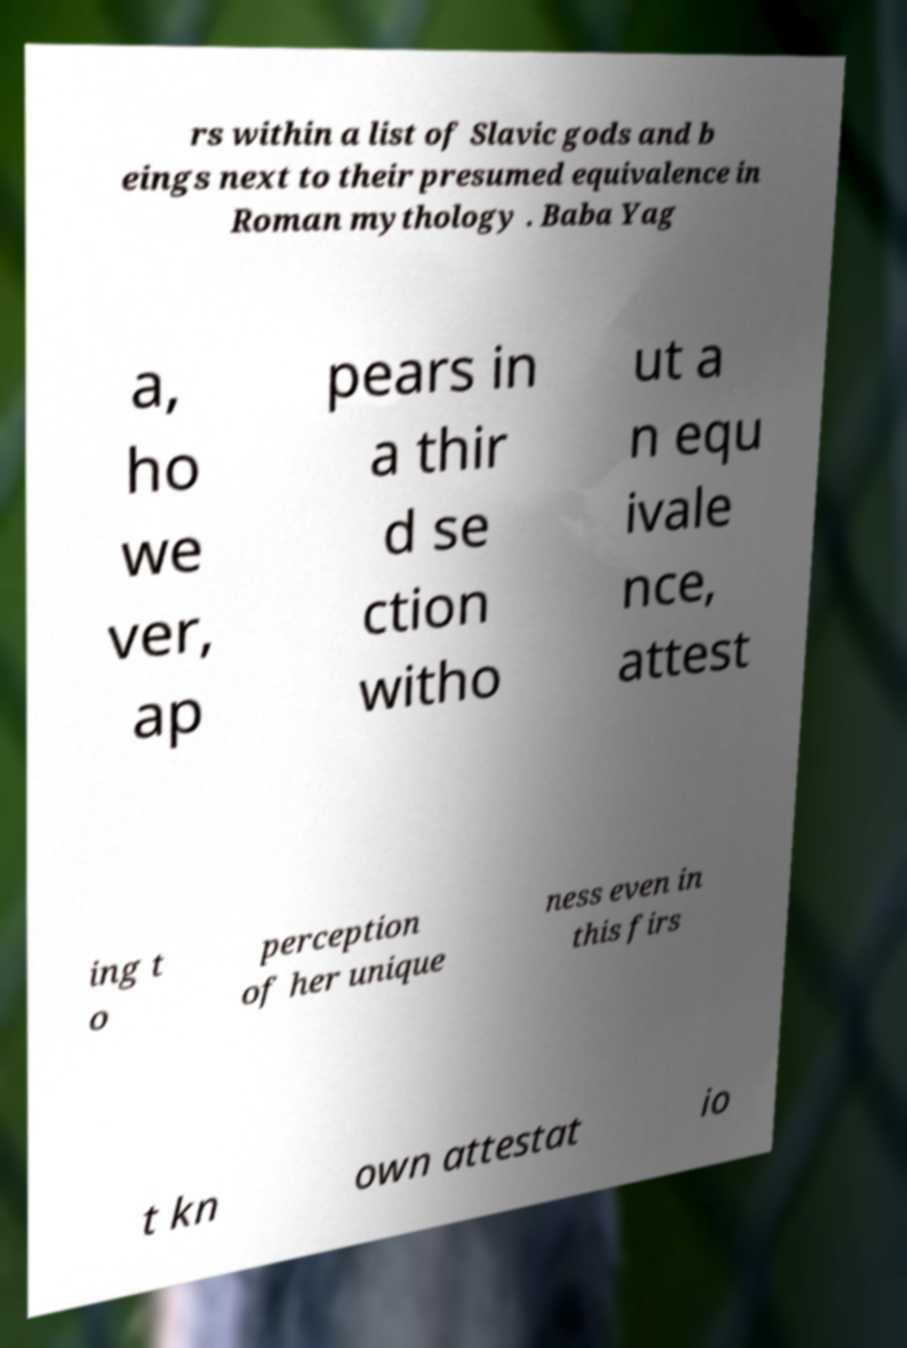I need the written content from this picture converted into text. Can you do that? rs within a list of Slavic gods and b eings next to their presumed equivalence in Roman mythology . Baba Yag a, ho we ver, ap pears in a thir d se ction witho ut a n equ ivale nce, attest ing t o perception of her unique ness even in this firs t kn own attestat io 